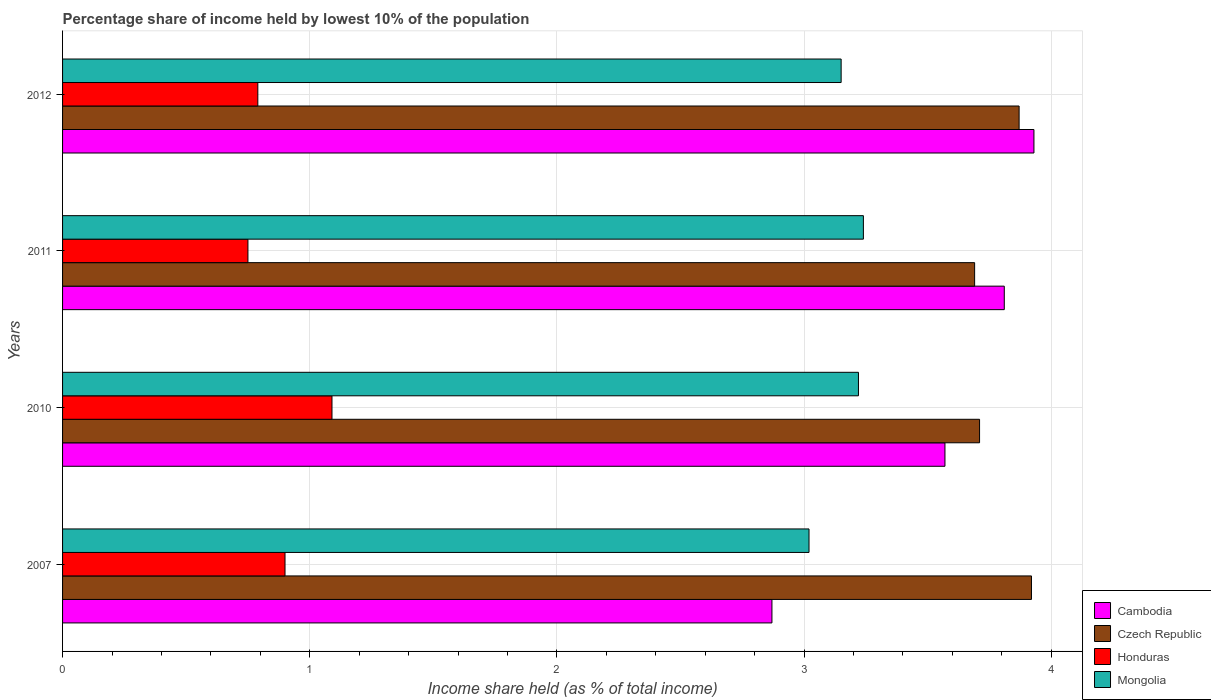How many groups of bars are there?
Give a very brief answer. 4. Are the number of bars per tick equal to the number of legend labels?
Give a very brief answer. Yes. How many bars are there on the 4th tick from the top?
Provide a succinct answer. 4. How many bars are there on the 2nd tick from the bottom?
Offer a terse response. 4. What is the label of the 2nd group of bars from the top?
Give a very brief answer. 2011. What is the percentage share of income held by lowest 10% of the population in Honduras in 2012?
Offer a terse response. 0.79. Across all years, what is the maximum percentage share of income held by lowest 10% of the population in Mongolia?
Your answer should be very brief. 3.24. In which year was the percentage share of income held by lowest 10% of the population in Honduras maximum?
Ensure brevity in your answer.  2010. In which year was the percentage share of income held by lowest 10% of the population in Mongolia minimum?
Make the answer very short. 2007. What is the total percentage share of income held by lowest 10% of the population in Cambodia in the graph?
Offer a terse response. 14.18. What is the difference between the percentage share of income held by lowest 10% of the population in Czech Republic in 2007 and that in 2010?
Offer a terse response. 0.21. What is the difference between the percentage share of income held by lowest 10% of the population in Cambodia in 2010 and the percentage share of income held by lowest 10% of the population in Honduras in 2007?
Keep it short and to the point. 2.67. What is the average percentage share of income held by lowest 10% of the population in Mongolia per year?
Provide a short and direct response. 3.16. In the year 2011, what is the difference between the percentage share of income held by lowest 10% of the population in Mongolia and percentage share of income held by lowest 10% of the population in Cambodia?
Make the answer very short. -0.57. What is the ratio of the percentage share of income held by lowest 10% of the population in Czech Republic in 2011 to that in 2012?
Your answer should be very brief. 0.95. Is the difference between the percentage share of income held by lowest 10% of the population in Mongolia in 2007 and 2010 greater than the difference between the percentage share of income held by lowest 10% of the population in Cambodia in 2007 and 2010?
Offer a very short reply. Yes. What is the difference between the highest and the second highest percentage share of income held by lowest 10% of the population in Honduras?
Your answer should be compact. 0.19. What is the difference between the highest and the lowest percentage share of income held by lowest 10% of the population in Czech Republic?
Keep it short and to the point. 0.23. In how many years, is the percentage share of income held by lowest 10% of the population in Honduras greater than the average percentage share of income held by lowest 10% of the population in Honduras taken over all years?
Your answer should be very brief. 2. Is the sum of the percentage share of income held by lowest 10% of the population in Cambodia in 2007 and 2010 greater than the maximum percentage share of income held by lowest 10% of the population in Czech Republic across all years?
Offer a terse response. Yes. Is it the case that in every year, the sum of the percentage share of income held by lowest 10% of the population in Cambodia and percentage share of income held by lowest 10% of the population in Czech Republic is greater than the sum of percentage share of income held by lowest 10% of the population in Honduras and percentage share of income held by lowest 10% of the population in Mongolia?
Give a very brief answer. Yes. What does the 1st bar from the top in 2011 represents?
Ensure brevity in your answer.  Mongolia. What does the 3rd bar from the bottom in 2012 represents?
Your response must be concise. Honduras. Is it the case that in every year, the sum of the percentage share of income held by lowest 10% of the population in Mongolia and percentage share of income held by lowest 10% of the population in Honduras is greater than the percentage share of income held by lowest 10% of the population in Czech Republic?
Keep it short and to the point. No. How many years are there in the graph?
Offer a very short reply. 4. What is the difference between two consecutive major ticks on the X-axis?
Give a very brief answer. 1. Does the graph contain any zero values?
Give a very brief answer. No. How many legend labels are there?
Keep it short and to the point. 4. What is the title of the graph?
Offer a very short reply. Percentage share of income held by lowest 10% of the population. What is the label or title of the X-axis?
Your answer should be compact. Income share held (as % of total income). What is the label or title of the Y-axis?
Offer a very short reply. Years. What is the Income share held (as % of total income) of Cambodia in 2007?
Your response must be concise. 2.87. What is the Income share held (as % of total income) of Czech Republic in 2007?
Keep it short and to the point. 3.92. What is the Income share held (as % of total income) of Mongolia in 2007?
Provide a short and direct response. 3.02. What is the Income share held (as % of total income) of Cambodia in 2010?
Your answer should be very brief. 3.57. What is the Income share held (as % of total income) in Czech Republic in 2010?
Your response must be concise. 3.71. What is the Income share held (as % of total income) of Honduras in 2010?
Ensure brevity in your answer.  1.09. What is the Income share held (as % of total income) in Mongolia in 2010?
Provide a succinct answer. 3.22. What is the Income share held (as % of total income) of Cambodia in 2011?
Keep it short and to the point. 3.81. What is the Income share held (as % of total income) of Czech Republic in 2011?
Give a very brief answer. 3.69. What is the Income share held (as % of total income) in Mongolia in 2011?
Make the answer very short. 3.24. What is the Income share held (as % of total income) of Cambodia in 2012?
Provide a succinct answer. 3.93. What is the Income share held (as % of total income) in Czech Republic in 2012?
Provide a short and direct response. 3.87. What is the Income share held (as % of total income) of Honduras in 2012?
Provide a succinct answer. 0.79. What is the Income share held (as % of total income) in Mongolia in 2012?
Offer a very short reply. 3.15. Across all years, what is the maximum Income share held (as % of total income) of Cambodia?
Your answer should be very brief. 3.93. Across all years, what is the maximum Income share held (as % of total income) in Czech Republic?
Offer a terse response. 3.92. Across all years, what is the maximum Income share held (as % of total income) of Honduras?
Your answer should be compact. 1.09. Across all years, what is the maximum Income share held (as % of total income) of Mongolia?
Provide a succinct answer. 3.24. Across all years, what is the minimum Income share held (as % of total income) of Cambodia?
Your response must be concise. 2.87. Across all years, what is the minimum Income share held (as % of total income) in Czech Republic?
Ensure brevity in your answer.  3.69. Across all years, what is the minimum Income share held (as % of total income) of Honduras?
Provide a short and direct response. 0.75. Across all years, what is the minimum Income share held (as % of total income) in Mongolia?
Your answer should be compact. 3.02. What is the total Income share held (as % of total income) in Cambodia in the graph?
Your answer should be very brief. 14.18. What is the total Income share held (as % of total income) of Czech Republic in the graph?
Offer a very short reply. 15.19. What is the total Income share held (as % of total income) in Honduras in the graph?
Make the answer very short. 3.53. What is the total Income share held (as % of total income) of Mongolia in the graph?
Make the answer very short. 12.63. What is the difference between the Income share held (as % of total income) in Czech Republic in 2007 and that in 2010?
Give a very brief answer. 0.21. What is the difference between the Income share held (as % of total income) in Honduras in 2007 and that in 2010?
Make the answer very short. -0.19. What is the difference between the Income share held (as % of total income) of Mongolia in 2007 and that in 2010?
Offer a terse response. -0.2. What is the difference between the Income share held (as % of total income) of Cambodia in 2007 and that in 2011?
Provide a short and direct response. -0.94. What is the difference between the Income share held (as % of total income) of Czech Republic in 2007 and that in 2011?
Your answer should be compact. 0.23. What is the difference between the Income share held (as % of total income) in Honduras in 2007 and that in 2011?
Your response must be concise. 0.15. What is the difference between the Income share held (as % of total income) of Mongolia in 2007 and that in 2011?
Offer a very short reply. -0.22. What is the difference between the Income share held (as % of total income) in Cambodia in 2007 and that in 2012?
Ensure brevity in your answer.  -1.06. What is the difference between the Income share held (as % of total income) in Czech Republic in 2007 and that in 2012?
Your answer should be very brief. 0.05. What is the difference between the Income share held (as % of total income) in Honduras in 2007 and that in 2012?
Provide a short and direct response. 0.11. What is the difference between the Income share held (as % of total income) in Mongolia in 2007 and that in 2012?
Provide a succinct answer. -0.13. What is the difference between the Income share held (as % of total income) in Cambodia in 2010 and that in 2011?
Provide a short and direct response. -0.24. What is the difference between the Income share held (as % of total income) of Honduras in 2010 and that in 2011?
Provide a short and direct response. 0.34. What is the difference between the Income share held (as % of total income) of Mongolia in 2010 and that in 2011?
Provide a succinct answer. -0.02. What is the difference between the Income share held (as % of total income) in Cambodia in 2010 and that in 2012?
Your response must be concise. -0.36. What is the difference between the Income share held (as % of total income) in Czech Republic in 2010 and that in 2012?
Make the answer very short. -0.16. What is the difference between the Income share held (as % of total income) of Mongolia in 2010 and that in 2012?
Provide a succinct answer. 0.07. What is the difference between the Income share held (as % of total income) of Cambodia in 2011 and that in 2012?
Your answer should be compact. -0.12. What is the difference between the Income share held (as % of total income) in Czech Republic in 2011 and that in 2012?
Keep it short and to the point. -0.18. What is the difference between the Income share held (as % of total income) in Honduras in 2011 and that in 2012?
Your answer should be very brief. -0.04. What is the difference between the Income share held (as % of total income) of Mongolia in 2011 and that in 2012?
Give a very brief answer. 0.09. What is the difference between the Income share held (as % of total income) in Cambodia in 2007 and the Income share held (as % of total income) in Czech Republic in 2010?
Provide a succinct answer. -0.84. What is the difference between the Income share held (as % of total income) of Cambodia in 2007 and the Income share held (as % of total income) of Honduras in 2010?
Your answer should be very brief. 1.78. What is the difference between the Income share held (as % of total income) in Cambodia in 2007 and the Income share held (as % of total income) in Mongolia in 2010?
Your response must be concise. -0.35. What is the difference between the Income share held (as % of total income) in Czech Republic in 2007 and the Income share held (as % of total income) in Honduras in 2010?
Provide a succinct answer. 2.83. What is the difference between the Income share held (as % of total income) in Czech Republic in 2007 and the Income share held (as % of total income) in Mongolia in 2010?
Your response must be concise. 0.7. What is the difference between the Income share held (as % of total income) of Honduras in 2007 and the Income share held (as % of total income) of Mongolia in 2010?
Offer a very short reply. -2.32. What is the difference between the Income share held (as % of total income) of Cambodia in 2007 and the Income share held (as % of total income) of Czech Republic in 2011?
Keep it short and to the point. -0.82. What is the difference between the Income share held (as % of total income) of Cambodia in 2007 and the Income share held (as % of total income) of Honduras in 2011?
Ensure brevity in your answer.  2.12. What is the difference between the Income share held (as % of total income) of Cambodia in 2007 and the Income share held (as % of total income) of Mongolia in 2011?
Your answer should be very brief. -0.37. What is the difference between the Income share held (as % of total income) in Czech Republic in 2007 and the Income share held (as % of total income) in Honduras in 2011?
Make the answer very short. 3.17. What is the difference between the Income share held (as % of total income) of Czech Republic in 2007 and the Income share held (as % of total income) of Mongolia in 2011?
Keep it short and to the point. 0.68. What is the difference between the Income share held (as % of total income) of Honduras in 2007 and the Income share held (as % of total income) of Mongolia in 2011?
Provide a succinct answer. -2.34. What is the difference between the Income share held (as % of total income) of Cambodia in 2007 and the Income share held (as % of total income) of Honduras in 2012?
Provide a short and direct response. 2.08. What is the difference between the Income share held (as % of total income) in Cambodia in 2007 and the Income share held (as % of total income) in Mongolia in 2012?
Provide a short and direct response. -0.28. What is the difference between the Income share held (as % of total income) in Czech Republic in 2007 and the Income share held (as % of total income) in Honduras in 2012?
Your response must be concise. 3.13. What is the difference between the Income share held (as % of total income) of Czech Republic in 2007 and the Income share held (as % of total income) of Mongolia in 2012?
Give a very brief answer. 0.77. What is the difference between the Income share held (as % of total income) of Honduras in 2007 and the Income share held (as % of total income) of Mongolia in 2012?
Make the answer very short. -2.25. What is the difference between the Income share held (as % of total income) in Cambodia in 2010 and the Income share held (as % of total income) in Czech Republic in 2011?
Provide a succinct answer. -0.12. What is the difference between the Income share held (as % of total income) of Cambodia in 2010 and the Income share held (as % of total income) of Honduras in 2011?
Give a very brief answer. 2.82. What is the difference between the Income share held (as % of total income) in Cambodia in 2010 and the Income share held (as % of total income) in Mongolia in 2011?
Give a very brief answer. 0.33. What is the difference between the Income share held (as % of total income) of Czech Republic in 2010 and the Income share held (as % of total income) of Honduras in 2011?
Offer a very short reply. 2.96. What is the difference between the Income share held (as % of total income) of Czech Republic in 2010 and the Income share held (as % of total income) of Mongolia in 2011?
Ensure brevity in your answer.  0.47. What is the difference between the Income share held (as % of total income) in Honduras in 2010 and the Income share held (as % of total income) in Mongolia in 2011?
Provide a succinct answer. -2.15. What is the difference between the Income share held (as % of total income) in Cambodia in 2010 and the Income share held (as % of total income) in Honduras in 2012?
Make the answer very short. 2.78. What is the difference between the Income share held (as % of total income) of Cambodia in 2010 and the Income share held (as % of total income) of Mongolia in 2012?
Your answer should be compact. 0.42. What is the difference between the Income share held (as % of total income) of Czech Republic in 2010 and the Income share held (as % of total income) of Honduras in 2012?
Ensure brevity in your answer.  2.92. What is the difference between the Income share held (as % of total income) of Czech Republic in 2010 and the Income share held (as % of total income) of Mongolia in 2012?
Offer a terse response. 0.56. What is the difference between the Income share held (as % of total income) of Honduras in 2010 and the Income share held (as % of total income) of Mongolia in 2012?
Your response must be concise. -2.06. What is the difference between the Income share held (as % of total income) in Cambodia in 2011 and the Income share held (as % of total income) in Czech Republic in 2012?
Provide a succinct answer. -0.06. What is the difference between the Income share held (as % of total income) of Cambodia in 2011 and the Income share held (as % of total income) of Honduras in 2012?
Offer a terse response. 3.02. What is the difference between the Income share held (as % of total income) of Cambodia in 2011 and the Income share held (as % of total income) of Mongolia in 2012?
Your answer should be very brief. 0.66. What is the difference between the Income share held (as % of total income) in Czech Republic in 2011 and the Income share held (as % of total income) in Mongolia in 2012?
Give a very brief answer. 0.54. What is the average Income share held (as % of total income) of Cambodia per year?
Provide a succinct answer. 3.54. What is the average Income share held (as % of total income) in Czech Republic per year?
Your answer should be very brief. 3.8. What is the average Income share held (as % of total income) in Honduras per year?
Offer a very short reply. 0.88. What is the average Income share held (as % of total income) in Mongolia per year?
Your answer should be very brief. 3.16. In the year 2007, what is the difference between the Income share held (as % of total income) in Cambodia and Income share held (as % of total income) in Czech Republic?
Give a very brief answer. -1.05. In the year 2007, what is the difference between the Income share held (as % of total income) of Cambodia and Income share held (as % of total income) of Honduras?
Your answer should be very brief. 1.97. In the year 2007, what is the difference between the Income share held (as % of total income) of Cambodia and Income share held (as % of total income) of Mongolia?
Offer a terse response. -0.15. In the year 2007, what is the difference between the Income share held (as % of total income) of Czech Republic and Income share held (as % of total income) of Honduras?
Offer a terse response. 3.02. In the year 2007, what is the difference between the Income share held (as % of total income) in Czech Republic and Income share held (as % of total income) in Mongolia?
Provide a succinct answer. 0.9. In the year 2007, what is the difference between the Income share held (as % of total income) in Honduras and Income share held (as % of total income) in Mongolia?
Your answer should be compact. -2.12. In the year 2010, what is the difference between the Income share held (as % of total income) of Cambodia and Income share held (as % of total income) of Czech Republic?
Your answer should be compact. -0.14. In the year 2010, what is the difference between the Income share held (as % of total income) in Cambodia and Income share held (as % of total income) in Honduras?
Provide a short and direct response. 2.48. In the year 2010, what is the difference between the Income share held (as % of total income) of Czech Republic and Income share held (as % of total income) of Honduras?
Ensure brevity in your answer.  2.62. In the year 2010, what is the difference between the Income share held (as % of total income) in Czech Republic and Income share held (as % of total income) in Mongolia?
Offer a very short reply. 0.49. In the year 2010, what is the difference between the Income share held (as % of total income) of Honduras and Income share held (as % of total income) of Mongolia?
Your answer should be compact. -2.13. In the year 2011, what is the difference between the Income share held (as % of total income) in Cambodia and Income share held (as % of total income) in Czech Republic?
Your answer should be compact. 0.12. In the year 2011, what is the difference between the Income share held (as % of total income) of Cambodia and Income share held (as % of total income) of Honduras?
Offer a very short reply. 3.06. In the year 2011, what is the difference between the Income share held (as % of total income) of Cambodia and Income share held (as % of total income) of Mongolia?
Provide a succinct answer. 0.57. In the year 2011, what is the difference between the Income share held (as % of total income) in Czech Republic and Income share held (as % of total income) in Honduras?
Keep it short and to the point. 2.94. In the year 2011, what is the difference between the Income share held (as % of total income) in Czech Republic and Income share held (as % of total income) in Mongolia?
Offer a terse response. 0.45. In the year 2011, what is the difference between the Income share held (as % of total income) of Honduras and Income share held (as % of total income) of Mongolia?
Keep it short and to the point. -2.49. In the year 2012, what is the difference between the Income share held (as % of total income) in Cambodia and Income share held (as % of total income) in Honduras?
Ensure brevity in your answer.  3.14. In the year 2012, what is the difference between the Income share held (as % of total income) of Cambodia and Income share held (as % of total income) of Mongolia?
Your response must be concise. 0.78. In the year 2012, what is the difference between the Income share held (as % of total income) in Czech Republic and Income share held (as % of total income) in Honduras?
Your answer should be compact. 3.08. In the year 2012, what is the difference between the Income share held (as % of total income) of Czech Republic and Income share held (as % of total income) of Mongolia?
Your answer should be compact. 0.72. In the year 2012, what is the difference between the Income share held (as % of total income) of Honduras and Income share held (as % of total income) of Mongolia?
Your response must be concise. -2.36. What is the ratio of the Income share held (as % of total income) in Cambodia in 2007 to that in 2010?
Your answer should be very brief. 0.8. What is the ratio of the Income share held (as % of total income) in Czech Republic in 2007 to that in 2010?
Give a very brief answer. 1.06. What is the ratio of the Income share held (as % of total income) in Honduras in 2007 to that in 2010?
Your response must be concise. 0.83. What is the ratio of the Income share held (as % of total income) of Mongolia in 2007 to that in 2010?
Offer a very short reply. 0.94. What is the ratio of the Income share held (as % of total income) in Cambodia in 2007 to that in 2011?
Offer a very short reply. 0.75. What is the ratio of the Income share held (as % of total income) in Czech Republic in 2007 to that in 2011?
Offer a terse response. 1.06. What is the ratio of the Income share held (as % of total income) in Honduras in 2007 to that in 2011?
Give a very brief answer. 1.2. What is the ratio of the Income share held (as % of total income) in Mongolia in 2007 to that in 2011?
Make the answer very short. 0.93. What is the ratio of the Income share held (as % of total income) in Cambodia in 2007 to that in 2012?
Your response must be concise. 0.73. What is the ratio of the Income share held (as % of total income) of Czech Republic in 2007 to that in 2012?
Provide a short and direct response. 1.01. What is the ratio of the Income share held (as % of total income) in Honduras in 2007 to that in 2012?
Make the answer very short. 1.14. What is the ratio of the Income share held (as % of total income) in Mongolia in 2007 to that in 2012?
Your answer should be compact. 0.96. What is the ratio of the Income share held (as % of total income) of Cambodia in 2010 to that in 2011?
Offer a terse response. 0.94. What is the ratio of the Income share held (as % of total income) of Czech Republic in 2010 to that in 2011?
Ensure brevity in your answer.  1.01. What is the ratio of the Income share held (as % of total income) in Honduras in 2010 to that in 2011?
Make the answer very short. 1.45. What is the ratio of the Income share held (as % of total income) of Cambodia in 2010 to that in 2012?
Your response must be concise. 0.91. What is the ratio of the Income share held (as % of total income) of Czech Republic in 2010 to that in 2012?
Make the answer very short. 0.96. What is the ratio of the Income share held (as % of total income) in Honduras in 2010 to that in 2012?
Your answer should be compact. 1.38. What is the ratio of the Income share held (as % of total income) in Mongolia in 2010 to that in 2012?
Your answer should be very brief. 1.02. What is the ratio of the Income share held (as % of total income) in Cambodia in 2011 to that in 2012?
Provide a short and direct response. 0.97. What is the ratio of the Income share held (as % of total income) in Czech Republic in 2011 to that in 2012?
Your answer should be compact. 0.95. What is the ratio of the Income share held (as % of total income) of Honduras in 2011 to that in 2012?
Give a very brief answer. 0.95. What is the ratio of the Income share held (as % of total income) of Mongolia in 2011 to that in 2012?
Your response must be concise. 1.03. What is the difference between the highest and the second highest Income share held (as % of total income) of Cambodia?
Keep it short and to the point. 0.12. What is the difference between the highest and the second highest Income share held (as % of total income) of Czech Republic?
Offer a very short reply. 0.05. What is the difference between the highest and the second highest Income share held (as % of total income) in Honduras?
Your answer should be compact. 0.19. What is the difference between the highest and the second highest Income share held (as % of total income) of Mongolia?
Your response must be concise. 0.02. What is the difference between the highest and the lowest Income share held (as % of total income) of Cambodia?
Your response must be concise. 1.06. What is the difference between the highest and the lowest Income share held (as % of total income) of Czech Republic?
Your response must be concise. 0.23. What is the difference between the highest and the lowest Income share held (as % of total income) of Honduras?
Make the answer very short. 0.34. What is the difference between the highest and the lowest Income share held (as % of total income) in Mongolia?
Ensure brevity in your answer.  0.22. 